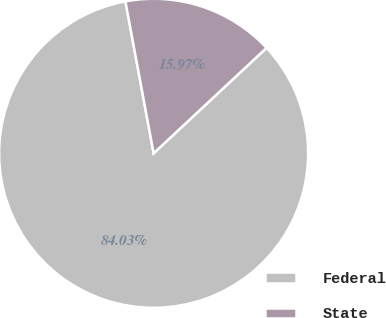Convert chart. <chart><loc_0><loc_0><loc_500><loc_500><pie_chart><fcel>Federal<fcel>State<nl><fcel>84.03%<fcel>15.97%<nl></chart> 